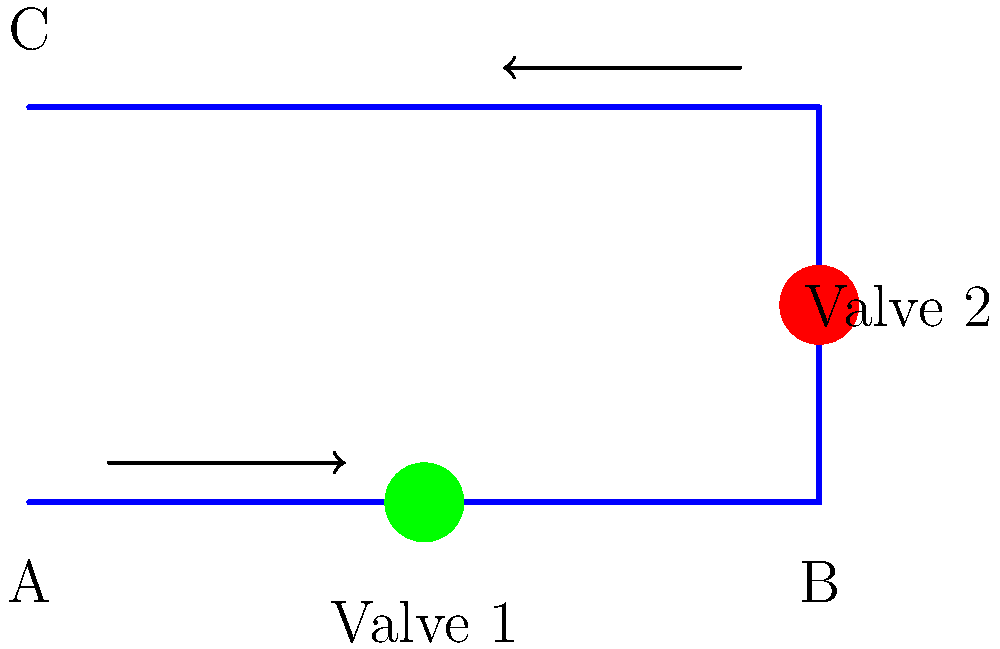In the pipe system shown, water flows from point A to point C. Valve 1 is fully open, while Valve 2 is partially closed. If the pressure at point A is 100 kPa and the pressure at point C is 80 kPa, what is the total pressure drop in the system? Assume no change in elevation. To determine the total pressure drop in the system, we need to follow these steps:

1. Identify the initial and final pressures:
   - Pressure at point A (initial): $P_A = 100$ kPa
   - Pressure at point C (final): $P_C = 80$ kPa

2. Calculate the pressure drop:
   The pressure drop is the difference between the initial and final pressures.
   $$\Delta P = P_A - P_C$$
   $$\Delta P = 100 \text{ kPa} - 80 \text{ kPa}$$
   $$\Delta P = 20 \text{ kPa}$$

3. Understand the causes of pressure drop:
   The pressure drop in this system is due to:
   a) Friction losses in the pipes
   b) Minor losses in the bends (90-degree turns)
   c) Additional losses in Valve 2 (partially closed)

   Note that Valve 1, being fully open, contributes minimal additional pressure drop.

4. Conclusion:
   The total pressure drop in the system is 20 kPa, which accounts for all losses mentioned above.
Answer: 20 kPa 